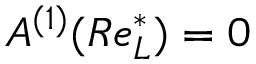Convert formula to latex. <formula><loc_0><loc_0><loc_500><loc_500>A ^ { ( 1 ) } ( R e _ { L } ^ { * } ) = 0</formula> 